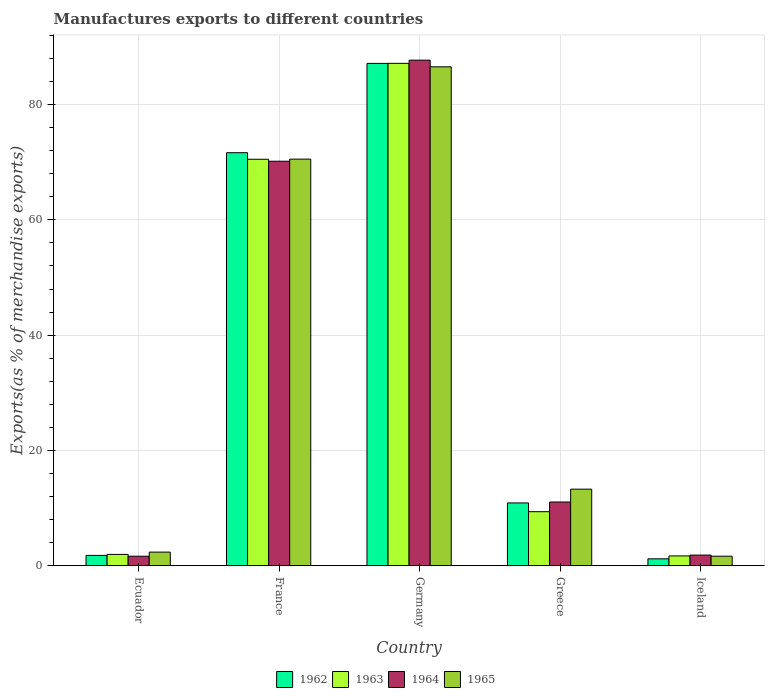How many different coloured bars are there?
Your answer should be compact. 4. How many groups of bars are there?
Your answer should be compact. 5. Are the number of bars per tick equal to the number of legend labels?
Provide a succinct answer. Yes. How many bars are there on the 2nd tick from the left?
Your response must be concise. 4. What is the label of the 1st group of bars from the left?
Make the answer very short. Ecuador. What is the percentage of exports to different countries in 1965 in Iceland?
Your answer should be very brief. 1.66. Across all countries, what is the maximum percentage of exports to different countries in 1965?
Offer a very short reply. 86.53. Across all countries, what is the minimum percentage of exports to different countries in 1965?
Ensure brevity in your answer.  1.66. In which country was the percentage of exports to different countries in 1962 maximum?
Provide a succinct answer. Germany. What is the total percentage of exports to different countries in 1964 in the graph?
Provide a succinct answer. 172.43. What is the difference between the percentage of exports to different countries in 1965 in France and that in Iceland?
Offer a very short reply. 68.86. What is the difference between the percentage of exports to different countries in 1962 in Ecuador and the percentage of exports to different countries in 1963 in Germany?
Your response must be concise. -85.33. What is the average percentage of exports to different countries in 1964 per country?
Provide a succinct answer. 34.49. What is the difference between the percentage of exports to different countries of/in 1964 and percentage of exports to different countries of/in 1965 in Germany?
Your response must be concise. 1.16. What is the ratio of the percentage of exports to different countries in 1962 in Greece to that in Iceland?
Your answer should be compact. 9.01. Is the percentage of exports to different countries in 1962 in France less than that in Iceland?
Keep it short and to the point. No. What is the difference between the highest and the second highest percentage of exports to different countries in 1964?
Your answer should be very brief. -59.1. What is the difference between the highest and the lowest percentage of exports to different countries in 1963?
Make the answer very short. 85.42. In how many countries, is the percentage of exports to different countries in 1962 greater than the average percentage of exports to different countries in 1962 taken over all countries?
Give a very brief answer. 2. Is the sum of the percentage of exports to different countries in 1962 in Ecuador and Greece greater than the maximum percentage of exports to different countries in 1963 across all countries?
Offer a terse response. No. Is it the case that in every country, the sum of the percentage of exports to different countries in 1962 and percentage of exports to different countries in 1963 is greater than the sum of percentage of exports to different countries in 1964 and percentage of exports to different countries in 1965?
Give a very brief answer. No. What does the 3rd bar from the left in France represents?
Give a very brief answer. 1964. What does the 2nd bar from the right in France represents?
Offer a very short reply. 1964. Is it the case that in every country, the sum of the percentage of exports to different countries in 1964 and percentage of exports to different countries in 1965 is greater than the percentage of exports to different countries in 1962?
Offer a very short reply. Yes. Does the graph contain any zero values?
Your response must be concise. No. Does the graph contain grids?
Provide a short and direct response. Yes. Where does the legend appear in the graph?
Provide a succinct answer. Bottom center. How are the legend labels stacked?
Offer a terse response. Horizontal. What is the title of the graph?
Your response must be concise. Manufactures exports to different countries. Does "1978" appear as one of the legend labels in the graph?
Ensure brevity in your answer.  No. What is the label or title of the X-axis?
Your response must be concise. Country. What is the label or title of the Y-axis?
Make the answer very short. Exports(as % of merchandise exports). What is the Exports(as % of merchandise exports) in 1962 in Ecuador?
Ensure brevity in your answer.  1.8. What is the Exports(as % of merchandise exports) of 1963 in Ecuador?
Your answer should be very brief. 1.97. What is the Exports(as % of merchandise exports) in 1964 in Ecuador?
Your answer should be very brief. 1.66. What is the Exports(as % of merchandise exports) in 1965 in Ecuador?
Ensure brevity in your answer.  2.37. What is the Exports(as % of merchandise exports) in 1962 in France?
Give a very brief answer. 71.64. What is the Exports(as % of merchandise exports) of 1963 in France?
Provide a succinct answer. 70.5. What is the Exports(as % of merchandise exports) in 1964 in France?
Make the answer very short. 70.16. What is the Exports(as % of merchandise exports) in 1965 in France?
Your answer should be very brief. 70.52. What is the Exports(as % of merchandise exports) of 1962 in Germany?
Your response must be concise. 87.12. What is the Exports(as % of merchandise exports) in 1963 in Germany?
Your answer should be very brief. 87.13. What is the Exports(as % of merchandise exports) of 1964 in Germany?
Make the answer very short. 87.69. What is the Exports(as % of merchandise exports) in 1965 in Germany?
Offer a terse response. 86.53. What is the Exports(as % of merchandise exports) in 1962 in Greece?
Keep it short and to the point. 10.9. What is the Exports(as % of merchandise exports) in 1963 in Greece?
Keep it short and to the point. 9.38. What is the Exports(as % of merchandise exports) in 1964 in Greece?
Keep it short and to the point. 11.06. What is the Exports(as % of merchandise exports) of 1965 in Greece?
Keep it short and to the point. 13.29. What is the Exports(as % of merchandise exports) in 1962 in Iceland?
Offer a terse response. 1.21. What is the Exports(as % of merchandise exports) of 1963 in Iceland?
Keep it short and to the point. 1.71. What is the Exports(as % of merchandise exports) in 1964 in Iceland?
Ensure brevity in your answer.  1.86. What is the Exports(as % of merchandise exports) of 1965 in Iceland?
Your response must be concise. 1.66. Across all countries, what is the maximum Exports(as % of merchandise exports) in 1962?
Offer a very short reply. 87.12. Across all countries, what is the maximum Exports(as % of merchandise exports) in 1963?
Make the answer very short. 87.13. Across all countries, what is the maximum Exports(as % of merchandise exports) in 1964?
Offer a terse response. 87.69. Across all countries, what is the maximum Exports(as % of merchandise exports) of 1965?
Your response must be concise. 86.53. Across all countries, what is the minimum Exports(as % of merchandise exports) in 1962?
Your answer should be compact. 1.21. Across all countries, what is the minimum Exports(as % of merchandise exports) of 1963?
Ensure brevity in your answer.  1.71. Across all countries, what is the minimum Exports(as % of merchandise exports) in 1964?
Give a very brief answer. 1.66. Across all countries, what is the minimum Exports(as % of merchandise exports) in 1965?
Make the answer very short. 1.66. What is the total Exports(as % of merchandise exports) in 1962 in the graph?
Your response must be concise. 172.68. What is the total Exports(as % of merchandise exports) in 1963 in the graph?
Give a very brief answer. 170.7. What is the total Exports(as % of merchandise exports) of 1964 in the graph?
Your answer should be very brief. 172.43. What is the total Exports(as % of merchandise exports) in 1965 in the graph?
Make the answer very short. 174.38. What is the difference between the Exports(as % of merchandise exports) in 1962 in Ecuador and that in France?
Give a very brief answer. -69.83. What is the difference between the Exports(as % of merchandise exports) of 1963 in Ecuador and that in France?
Your answer should be very brief. -68.53. What is the difference between the Exports(as % of merchandise exports) in 1964 in Ecuador and that in France?
Make the answer very short. -68.5. What is the difference between the Exports(as % of merchandise exports) in 1965 in Ecuador and that in France?
Make the answer very short. -68.15. What is the difference between the Exports(as % of merchandise exports) in 1962 in Ecuador and that in Germany?
Keep it short and to the point. -85.32. What is the difference between the Exports(as % of merchandise exports) in 1963 in Ecuador and that in Germany?
Give a very brief answer. -85.16. What is the difference between the Exports(as % of merchandise exports) of 1964 in Ecuador and that in Germany?
Your response must be concise. -86.02. What is the difference between the Exports(as % of merchandise exports) in 1965 in Ecuador and that in Germany?
Your response must be concise. -84.15. What is the difference between the Exports(as % of merchandise exports) of 1962 in Ecuador and that in Greece?
Make the answer very short. -9.1. What is the difference between the Exports(as % of merchandise exports) of 1963 in Ecuador and that in Greece?
Your answer should be very brief. -7.41. What is the difference between the Exports(as % of merchandise exports) in 1964 in Ecuador and that in Greece?
Provide a short and direct response. -9.4. What is the difference between the Exports(as % of merchandise exports) of 1965 in Ecuador and that in Greece?
Your answer should be compact. -10.91. What is the difference between the Exports(as % of merchandise exports) in 1962 in Ecuador and that in Iceland?
Ensure brevity in your answer.  0.59. What is the difference between the Exports(as % of merchandise exports) in 1963 in Ecuador and that in Iceland?
Your answer should be very brief. 0.26. What is the difference between the Exports(as % of merchandise exports) of 1964 in Ecuador and that in Iceland?
Offer a very short reply. -0.19. What is the difference between the Exports(as % of merchandise exports) in 1965 in Ecuador and that in Iceland?
Offer a very short reply. 0.71. What is the difference between the Exports(as % of merchandise exports) of 1962 in France and that in Germany?
Offer a very short reply. -15.49. What is the difference between the Exports(as % of merchandise exports) in 1963 in France and that in Germany?
Provide a succinct answer. -16.63. What is the difference between the Exports(as % of merchandise exports) in 1964 in France and that in Germany?
Ensure brevity in your answer.  -17.53. What is the difference between the Exports(as % of merchandise exports) in 1965 in France and that in Germany?
Your response must be concise. -16.01. What is the difference between the Exports(as % of merchandise exports) in 1962 in France and that in Greece?
Provide a short and direct response. 60.73. What is the difference between the Exports(as % of merchandise exports) in 1963 in France and that in Greece?
Give a very brief answer. 61.12. What is the difference between the Exports(as % of merchandise exports) in 1964 in France and that in Greece?
Offer a very short reply. 59.1. What is the difference between the Exports(as % of merchandise exports) of 1965 in France and that in Greece?
Make the answer very short. 57.23. What is the difference between the Exports(as % of merchandise exports) of 1962 in France and that in Iceland?
Offer a very short reply. 70.43. What is the difference between the Exports(as % of merchandise exports) in 1963 in France and that in Iceland?
Your answer should be compact. 68.79. What is the difference between the Exports(as % of merchandise exports) in 1964 in France and that in Iceland?
Ensure brevity in your answer.  68.3. What is the difference between the Exports(as % of merchandise exports) of 1965 in France and that in Iceland?
Your response must be concise. 68.86. What is the difference between the Exports(as % of merchandise exports) in 1962 in Germany and that in Greece?
Give a very brief answer. 76.22. What is the difference between the Exports(as % of merchandise exports) in 1963 in Germany and that in Greece?
Provide a succinct answer. 77.75. What is the difference between the Exports(as % of merchandise exports) of 1964 in Germany and that in Greece?
Provide a succinct answer. 76.62. What is the difference between the Exports(as % of merchandise exports) in 1965 in Germany and that in Greece?
Offer a terse response. 73.24. What is the difference between the Exports(as % of merchandise exports) of 1962 in Germany and that in Iceland?
Provide a succinct answer. 85.91. What is the difference between the Exports(as % of merchandise exports) in 1963 in Germany and that in Iceland?
Ensure brevity in your answer.  85.42. What is the difference between the Exports(as % of merchandise exports) of 1964 in Germany and that in Iceland?
Your response must be concise. 85.83. What is the difference between the Exports(as % of merchandise exports) of 1965 in Germany and that in Iceland?
Give a very brief answer. 84.86. What is the difference between the Exports(as % of merchandise exports) of 1962 in Greece and that in Iceland?
Your answer should be compact. 9.69. What is the difference between the Exports(as % of merchandise exports) of 1963 in Greece and that in Iceland?
Make the answer very short. 7.67. What is the difference between the Exports(as % of merchandise exports) in 1964 in Greece and that in Iceland?
Your response must be concise. 9.21. What is the difference between the Exports(as % of merchandise exports) in 1965 in Greece and that in Iceland?
Your answer should be compact. 11.63. What is the difference between the Exports(as % of merchandise exports) of 1962 in Ecuador and the Exports(as % of merchandise exports) of 1963 in France?
Ensure brevity in your answer.  -68.7. What is the difference between the Exports(as % of merchandise exports) in 1962 in Ecuador and the Exports(as % of merchandise exports) in 1964 in France?
Provide a short and direct response. -68.35. What is the difference between the Exports(as % of merchandise exports) of 1962 in Ecuador and the Exports(as % of merchandise exports) of 1965 in France?
Keep it short and to the point. -68.72. What is the difference between the Exports(as % of merchandise exports) of 1963 in Ecuador and the Exports(as % of merchandise exports) of 1964 in France?
Ensure brevity in your answer.  -68.18. What is the difference between the Exports(as % of merchandise exports) in 1963 in Ecuador and the Exports(as % of merchandise exports) in 1965 in France?
Provide a short and direct response. -68.55. What is the difference between the Exports(as % of merchandise exports) of 1964 in Ecuador and the Exports(as % of merchandise exports) of 1965 in France?
Your response must be concise. -68.86. What is the difference between the Exports(as % of merchandise exports) of 1962 in Ecuador and the Exports(as % of merchandise exports) of 1963 in Germany?
Keep it short and to the point. -85.33. What is the difference between the Exports(as % of merchandise exports) in 1962 in Ecuador and the Exports(as % of merchandise exports) in 1964 in Germany?
Ensure brevity in your answer.  -85.88. What is the difference between the Exports(as % of merchandise exports) of 1962 in Ecuador and the Exports(as % of merchandise exports) of 1965 in Germany?
Keep it short and to the point. -84.72. What is the difference between the Exports(as % of merchandise exports) of 1963 in Ecuador and the Exports(as % of merchandise exports) of 1964 in Germany?
Ensure brevity in your answer.  -85.71. What is the difference between the Exports(as % of merchandise exports) of 1963 in Ecuador and the Exports(as % of merchandise exports) of 1965 in Germany?
Your response must be concise. -84.55. What is the difference between the Exports(as % of merchandise exports) in 1964 in Ecuador and the Exports(as % of merchandise exports) in 1965 in Germany?
Your answer should be very brief. -84.87. What is the difference between the Exports(as % of merchandise exports) of 1962 in Ecuador and the Exports(as % of merchandise exports) of 1963 in Greece?
Ensure brevity in your answer.  -7.58. What is the difference between the Exports(as % of merchandise exports) of 1962 in Ecuador and the Exports(as % of merchandise exports) of 1964 in Greece?
Give a very brief answer. -9.26. What is the difference between the Exports(as % of merchandise exports) in 1962 in Ecuador and the Exports(as % of merchandise exports) in 1965 in Greece?
Your answer should be very brief. -11.48. What is the difference between the Exports(as % of merchandise exports) in 1963 in Ecuador and the Exports(as % of merchandise exports) in 1964 in Greece?
Give a very brief answer. -9.09. What is the difference between the Exports(as % of merchandise exports) of 1963 in Ecuador and the Exports(as % of merchandise exports) of 1965 in Greece?
Ensure brevity in your answer.  -11.31. What is the difference between the Exports(as % of merchandise exports) in 1964 in Ecuador and the Exports(as % of merchandise exports) in 1965 in Greece?
Offer a very short reply. -11.63. What is the difference between the Exports(as % of merchandise exports) in 1962 in Ecuador and the Exports(as % of merchandise exports) in 1963 in Iceland?
Your answer should be very brief. 0.09. What is the difference between the Exports(as % of merchandise exports) in 1962 in Ecuador and the Exports(as % of merchandise exports) in 1964 in Iceland?
Provide a short and direct response. -0.05. What is the difference between the Exports(as % of merchandise exports) of 1962 in Ecuador and the Exports(as % of merchandise exports) of 1965 in Iceland?
Keep it short and to the point. 0.14. What is the difference between the Exports(as % of merchandise exports) in 1963 in Ecuador and the Exports(as % of merchandise exports) in 1964 in Iceland?
Your answer should be compact. 0.12. What is the difference between the Exports(as % of merchandise exports) of 1963 in Ecuador and the Exports(as % of merchandise exports) of 1965 in Iceland?
Provide a short and direct response. 0.31. What is the difference between the Exports(as % of merchandise exports) of 1964 in Ecuador and the Exports(as % of merchandise exports) of 1965 in Iceland?
Give a very brief answer. -0. What is the difference between the Exports(as % of merchandise exports) in 1962 in France and the Exports(as % of merchandise exports) in 1963 in Germany?
Your answer should be very brief. -15.5. What is the difference between the Exports(as % of merchandise exports) in 1962 in France and the Exports(as % of merchandise exports) in 1964 in Germany?
Your response must be concise. -16.05. What is the difference between the Exports(as % of merchandise exports) in 1962 in France and the Exports(as % of merchandise exports) in 1965 in Germany?
Ensure brevity in your answer.  -14.89. What is the difference between the Exports(as % of merchandise exports) of 1963 in France and the Exports(as % of merchandise exports) of 1964 in Germany?
Your response must be concise. -17.18. What is the difference between the Exports(as % of merchandise exports) in 1963 in France and the Exports(as % of merchandise exports) in 1965 in Germany?
Ensure brevity in your answer.  -16.03. What is the difference between the Exports(as % of merchandise exports) in 1964 in France and the Exports(as % of merchandise exports) in 1965 in Germany?
Provide a short and direct response. -16.37. What is the difference between the Exports(as % of merchandise exports) of 1962 in France and the Exports(as % of merchandise exports) of 1963 in Greece?
Your answer should be very brief. 62.25. What is the difference between the Exports(as % of merchandise exports) in 1962 in France and the Exports(as % of merchandise exports) in 1964 in Greece?
Offer a very short reply. 60.57. What is the difference between the Exports(as % of merchandise exports) in 1962 in France and the Exports(as % of merchandise exports) in 1965 in Greece?
Offer a very short reply. 58.35. What is the difference between the Exports(as % of merchandise exports) in 1963 in France and the Exports(as % of merchandise exports) in 1964 in Greece?
Provide a succinct answer. 59.44. What is the difference between the Exports(as % of merchandise exports) of 1963 in France and the Exports(as % of merchandise exports) of 1965 in Greece?
Your response must be concise. 57.21. What is the difference between the Exports(as % of merchandise exports) in 1964 in France and the Exports(as % of merchandise exports) in 1965 in Greece?
Keep it short and to the point. 56.87. What is the difference between the Exports(as % of merchandise exports) in 1962 in France and the Exports(as % of merchandise exports) in 1963 in Iceland?
Provide a succinct answer. 69.93. What is the difference between the Exports(as % of merchandise exports) in 1962 in France and the Exports(as % of merchandise exports) in 1964 in Iceland?
Your answer should be compact. 69.78. What is the difference between the Exports(as % of merchandise exports) of 1962 in France and the Exports(as % of merchandise exports) of 1965 in Iceland?
Provide a succinct answer. 69.97. What is the difference between the Exports(as % of merchandise exports) in 1963 in France and the Exports(as % of merchandise exports) in 1964 in Iceland?
Make the answer very short. 68.64. What is the difference between the Exports(as % of merchandise exports) in 1963 in France and the Exports(as % of merchandise exports) in 1965 in Iceland?
Keep it short and to the point. 68.84. What is the difference between the Exports(as % of merchandise exports) in 1964 in France and the Exports(as % of merchandise exports) in 1965 in Iceland?
Your answer should be compact. 68.5. What is the difference between the Exports(as % of merchandise exports) in 1962 in Germany and the Exports(as % of merchandise exports) in 1963 in Greece?
Your response must be concise. 77.74. What is the difference between the Exports(as % of merchandise exports) in 1962 in Germany and the Exports(as % of merchandise exports) in 1964 in Greece?
Keep it short and to the point. 76.06. What is the difference between the Exports(as % of merchandise exports) of 1962 in Germany and the Exports(as % of merchandise exports) of 1965 in Greece?
Offer a very short reply. 73.84. What is the difference between the Exports(as % of merchandise exports) in 1963 in Germany and the Exports(as % of merchandise exports) in 1964 in Greece?
Provide a succinct answer. 76.07. What is the difference between the Exports(as % of merchandise exports) of 1963 in Germany and the Exports(as % of merchandise exports) of 1965 in Greece?
Your response must be concise. 73.84. What is the difference between the Exports(as % of merchandise exports) in 1964 in Germany and the Exports(as % of merchandise exports) in 1965 in Greece?
Offer a terse response. 74.4. What is the difference between the Exports(as % of merchandise exports) of 1962 in Germany and the Exports(as % of merchandise exports) of 1963 in Iceland?
Your answer should be compact. 85.41. What is the difference between the Exports(as % of merchandise exports) of 1962 in Germany and the Exports(as % of merchandise exports) of 1964 in Iceland?
Your response must be concise. 85.27. What is the difference between the Exports(as % of merchandise exports) in 1962 in Germany and the Exports(as % of merchandise exports) in 1965 in Iceland?
Offer a terse response. 85.46. What is the difference between the Exports(as % of merchandise exports) of 1963 in Germany and the Exports(as % of merchandise exports) of 1964 in Iceland?
Provide a short and direct response. 85.28. What is the difference between the Exports(as % of merchandise exports) in 1963 in Germany and the Exports(as % of merchandise exports) in 1965 in Iceland?
Give a very brief answer. 85.47. What is the difference between the Exports(as % of merchandise exports) in 1964 in Germany and the Exports(as % of merchandise exports) in 1965 in Iceland?
Provide a short and direct response. 86.02. What is the difference between the Exports(as % of merchandise exports) in 1962 in Greece and the Exports(as % of merchandise exports) in 1963 in Iceland?
Your answer should be compact. 9.19. What is the difference between the Exports(as % of merchandise exports) in 1962 in Greece and the Exports(as % of merchandise exports) in 1964 in Iceland?
Keep it short and to the point. 9.05. What is the difference between the Exports(as % of merchandise exports) of 1962 in Greece and the Exports(as % of merchandise exports) of 1965 in Iceland?
Ensure brevity in your answer.  9.24. What is the difference between the Exports(as % of merchandise exports) in 1963 in Greece and the Exports(as % of merchandise exports) in 1964 in Iceland?
Offer a terse response. 7.52. What is the difference between the Exports(as % of merchandise exports) in 1963 in Greece and the Exports(as % of merchandise exports) in 1965 in Iceland?
Provide a short and direct response. 7.72. What is the difference between the Exports(as % of merchandise exports) of 1964 in Greece and the Exports(as % of merchandise exports) of 1965 in Iceland?
Your answer should be very brief. 9.4. What is the average Exports(as % of merchandise exports) in 1962 per country?
Your answer should be very brief. 34.54. What is the average Exports(as % of merchandise exports) of 1963 per country?
Provide a succinct answer. 34.14. What is the average Exports(as % of merchandise exports) in 1964 per country?
Offer a very short reply. 34.49. What is the average Exports(as % of merchandise exports) of 1965 per country?
Provide a short and direct response. 34.88. What is the difference between the Exports(as % of merchandise exports) of 1962 and Exports(as % of merchandise exports) of 1963 in Ecuador?
Your response must be concise. -0.17. What is the difference between the Exports(as % of merchandise exports) in 1962 and Exports(as % of merchandise exports) in 1964 in Ecuador?
Your response must be concise. 0.14. What is the difference between the Exports(as % of merchandise exports) of 1962 and Exports(as % of merchandise exports) of 1965 in Ecuador?
Your response must be concise. -0.57. What is the difference between the Exports(as % of merchandise exports) of 1963 and Exports(as % of merchandise exports) of 1964 in Ecuador?
Your answer should be compact. 0.31. What is the difference between the Exports(as % of merchandise exports) of 1963 and Exports(as % of merchandise exports) of 1965 in Ecuador?
Offer a terse response. -0.4. What is the difference between the Exports(as % of merchandise exports) of 1964 and Exports(as % of merchandise exports) of 1965 in Ecuador?
Your answer should be very brief. -0.71. What is the difference between the Exports(as % of merchandise exports) in 1962 and Exports(as % of merchandise exports) in 1963 in France?
Your answer should be very brief. 1.13. What is the difference between the Exports(as % of merchandise exports) of 1962 and Exports(as % of merchandise exports) of 1964 in France?
Give a very brief answer. 1.48. What is the difference between the Exports(as % of merchandise exports) in 1962 and Exports(as % of merchandise exports) in 1965 in France?
Give a very brief answer. 1.11. What is the difference between the Exports(as % of merchandise exports) in 1963 and Exports(as % of merchandise exports) in 1964 in France?
Offer a very short reply. 0.34. What is the difference between the Exports(as % of merchandise exports) of 1963 and Exports(as % of merchandise exports) of 1965 in France?
Your answer should be very brief. -0.02. What is the difference between the Exports(as % of merchandise exports) in 1964 and Exports(as % of merchandise exports) in 1965 in France?
Ensure brevity in your answer.  -0.36. What is the difference between the Exports(as % of merchandise exports) of 1962 and Exports(as % of merchandise exports) of 1963 in Germany?
Give a very brief answer. -0.01. What is the difference between the Exports(as % of merchandise exports) in 1962 and Exports(as % of merchandise exports) in 1964 in Germany?
Your answer should be compact. -0.56. What is the difference between the Exports(as % of merchandise exports) of 1962 and Exports(as % of merchandise exports) of 1965 in Germany?
Provide a short and direct response. 0.6. What is the difference between the Exports(as % of merchandise exports) of 1963 and Exports(as % of merchandise exports) of 1964 in Germany?
Ensure brevity in your answer.  -0.55. What is the difference between the Exports(as % of merchandise exports) in 1963 and Exports(as % of merchandise exports) in 1965 in Germany?
Keep it short and to the point. 0.6. What is the difference between the Exports(as % of merchandise exports) in 1964 and Exports(as % of merchandise exports) in 1965 in Germany?
Keep it short and to the point. 1.16. What is the difference between the Exports(as % of merchandise exports) of 1962 and Exports(as % of merchandise exports) of 1963 in Greece?
Your response must be concise. 1.52. What is the difference between the Exports(as % of merchandise exports) of 1962 and Exports(as % of merchandise exports) of 1964 in Greece?
Your response must be concise. -0.16. What is the difference between the Exports(as % of merchandise exports) in 1962 and Exports(as % of merchandise exports) in 1965 in Greece?
Ensure brevity in your answer.  -2.39. What is the difference between the Exports(as % of merchandise exports) in 1963 and Exports(as % of merchandise exports) in 1964 in Greece?
Provide a short and direct response. -1.68. What is the difference between the Exports(as % of merchandise exports) of 1963 and Exports(as % of merchandise exports) of 1965 in Greece?
Give a very brief answer. -3.91. What is the difference between the Exports(as % of merchandise exports) of 1964 and Exports(as % of merchandise exports) of 1965 in Greece?
Provide a succinct answer. -2.23. What is the difference between the Exports(as % of merchandise exports) of 1962 and Exports(as % of merchandise exports) of 1964 in Iceland?
Give a very brief answer. -0.65. What is the difference between the Exports(as % of merchandise exports) in 1962 and Exports(as % of merchandise exports) in 1965 in Iceland?
Give a very brief answer. -0.45. What is the difference between the Exports(as % of merchandise exports) in 1963 and Exports(as % of merchandise exports) in 1964 in Iceland?
Your response must be concise. -0.15. What is the difference between the Exports(as % of merchandise exports) in 1963 and Exports(as % of merchandise exports) in 1965 in Iceland?
Provide a succinct answer. 0.05. What is the difference between the Exports(as % of merchandise exports) in 1964 and Exports(as % of merchandise exports) in 1965 in Iceland?
Make the answer very short. 0.19. What is the ratio of the Exports(as % of merchandise exports) of 1962 in Ecuador to that in France?
Ensure brevity in your answer.  0.03. What is the ratio of the Exports(as % of merchandise exports) of 1963 in Ecuador to that in France?
Your answer should be very brief. 0.03. What is the ratio of the Exports(as % of merchandise exports) of 1964 in Ecuador to that in France?
Provide a succinct answer. 0.02. What is the ratio of the Exports(as % of merchandise exports) of 1965 in Ecuador to that in France?
Provide a short and direct response. 0.03. What is the ratio of the Exports(as % of merchandise exports) in 1962 in Ecuador to that in Germany?
Provide a succinct answer. 0.02. What is the ratio of the Exports(as % of merchandise exports) in 1963 in Ecuador to that in Germany?
Your answer should be very brief. 0.02. What is the ratio of the Exports(as % of merchandise exports) of 1964 in Ecuador to that in Germany?
Ensure brevity in your answer.  0.02. What is the ratio of the Exports(as % of merchandise exports) in 1965 in Ecuador to that in Germany?
Your answer should be compact. 0.03. What is the ratio of the Exports(as % of merchandise exports) in 1962 in Ecuador to that in Greece?
Offer a very short reply. 0.17. What is the ratio of the Exports(as % of merchandise exports) of 1963 in Ecuador to that in Greece?
Offer a terse response. 0.21. What is the ratio of the Exports(as % of merchandise exports) of 1964 in Ecuador to that in Greece?
Your answer should be compact. 0.15. What is the ratio of the Exports(as % of merchandise exports) of 1965 in Ecuador to that in Greece?
Give a very brief answer. 0.18. What is the ratio of the Exports(as % of merchandise exports) in 1962 in Ecuador to that in Iceland?
Make the answer very short. 1.49. What is the ratio of the Exports(as % of merchandise exports) in 1963 in Ecuador to that in Iceland?
Offer a terse response. 1.15. What is the ratio of the Exports(as % of merchandise exports) in 1964 in Ecuador to that in Iceland?
Provide a short and direct response. 0.9. What is the ratio of the Exports(as % of merchandise exports) in 1965 in Ecuador to that in Iceland?
Your response must be concise. 1.43. What is the ratio of the Exports(as % of merchandise exports) in 1962 in France to that in Germany?
Provide a succinct answer. 0.82. What is the ratio of the Exports(as % of merchandise exports) in 1963 in France to that in Germany?
Keep it short and to the point. 0.81. What is the ratio of the Exports(as % of merchandise exports) in 1964 in France to that in Germany?
Provide a short and direct response. 0.8. What is the ratio of the Exports(as % of merchandise exports) of 1965 in France to that in Germany?
Provide a succinct answer. 0.81. What is the ratio of the Exports(as % of merchandise exports) in 1962 in France to that in Greece?
Your answer should be very brief. 6.57. What is the ratio of the Exports(as % of merchandise exports) in 1963 in France to that in Greece?
Your response must be concise. 7.51. What is the ratio of the Exports(as % of merchandise exports) of 1964 in France to that in Greece?
Your response must be concise. 6.34. What is the ratio of the Exports(as % of merchandise exports) of 1965 in France to that in Greece?
Provide a succinct answer. 5.31. What is the ratio of the Exports(as % of merchandise exports) of 1962 in France to that in Iceland?
Your answer should be very brief. 59.19. What is the ratio of the Exports(as % of merchandise exports) in 1963 in France to that in Iceland?
Make the answer very short. 41.22. What is the ratio of the Exports(as % of merchandise exports) of 1964 in France to that in Iceland?
Provide a succinct answer. 37.78. What is the ratio of the Exports(as % of merchandise exports) in 1965 in France to that in Iceland?
Provide a short and direct response. 42.4. What is the ratio of the Exports(as % of merchandise exports) of 1962 in Germany to that in Greece?
Provide a short and direct response. 7.99. What is the ratio of the Exports(as % of merchandise exports) in 1963 in Germany to that in Greece?
Make the answer very short. 9.29. What is the ratio of the Exports(as % of merchandise exports) in 1964 in Germany to that in Greece?
Your answer should be very brief. 7.93. What is the ratio of the Exports(as % of merchandise exports) in 1965 in Germany to that in Greece?
Offer a very short reply. 6.51. What is the ratio of the Exports(as % of merchandise exports) of 1962 in Germany to that in Iceland?
Give a very brief answer. 71.98. What is the ratio of the Exports(as % of merchandise exports) of 1963 in Germany to that in Iceland?
Your answer should be very brief. 50.94. What is the ratio of the Exports(as % of merchandise exports) of 1964 in Germany to that in Iceland?
Offer a very short reply. 47.21. What is the ratio of the Exports(as % of merchandise exports) in 1965 in Germany to that in Iceland?
Offer a very short reply. 52.03. What is the ratio of the Exports(as % of merchandise exports) of 1962 in Greece to that in Iceland?
Ensure brevity in your answer.  9.01. What is the ratio of the Exports(as % of merchandise exports) of 1963 in Greece to that in Iceland?
Your response must be concise. 5.49. What is the ratio of the Exports(as % of merchandise exports) in 1964 in Greece to that in Iceland?
Provide a succinct answer. 5.96. What is the ratio of the Exports(as % of merchandise exports) of 1965 in Greece to that in Iceland?
Your answer should be very brief. 7.99. What is the difference between the highest and the second highest Exports(as % of merchandise exports) in 1962?
Offer a very short reply. 15.49. What is the difference between the highest and the second highest Exports(as % of merchandise exports) in 1963?
Keep it short and to the point. 16.63. What is the difference between the highest and the second highest Exports(as % of merchandise exports) of 1964?
Make the answer very short. 17.53. What is the difference between the highest and the second highest Exports(as % of merchandise exports) in 1965?
Your response must be concise. 16.01. What is the difference between the highest and the lowest Exports(as % of merchandise exports) in 1962?
Your response must be concise. 85.91. What is the difference between the highest and the lowest Exports(as % of merchandise exports) in 1963?
Your answer should be very brief. 85.42. What is the difference between the highest and the lowest Exports(as % of merchandise exports) in 1964?
Your answer should be compact. 86.02. What is the difference between the highest and the lowest Exports(as % of merchandise exports) in 1965?
Offer a terse response. 84.86. 